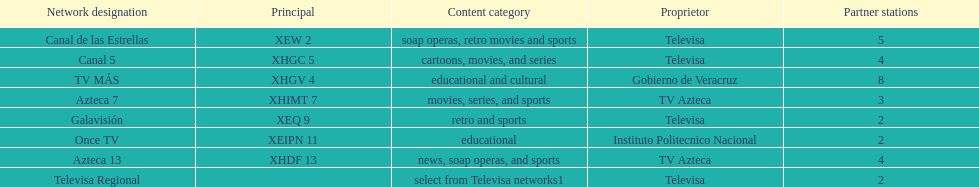Which is the only station with 8 affiliates? TV MÁS. 